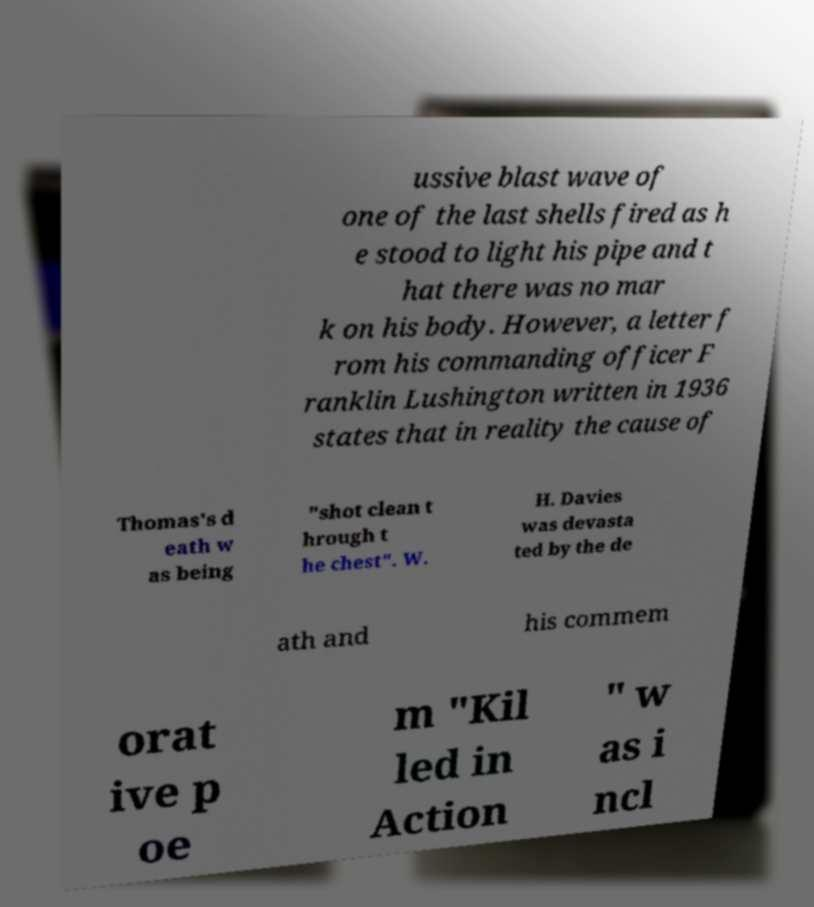For documentation purposes, I need the text within this image transcribed. Could you provide that? ussive blast wave of one of the last shells fired as h e stood to light his pipe and t hat there was no mar k on his body. However, a letter f rom his commanding officer F ranklin Lushington written in 1936 states that in reality the cause of Thomas's d eath w as being "shot clean t hrough t he chest". W. H. Davies was devasta ted by the de ath and his commem orat ive p oe m "Kil led in Action " w as i ncl 